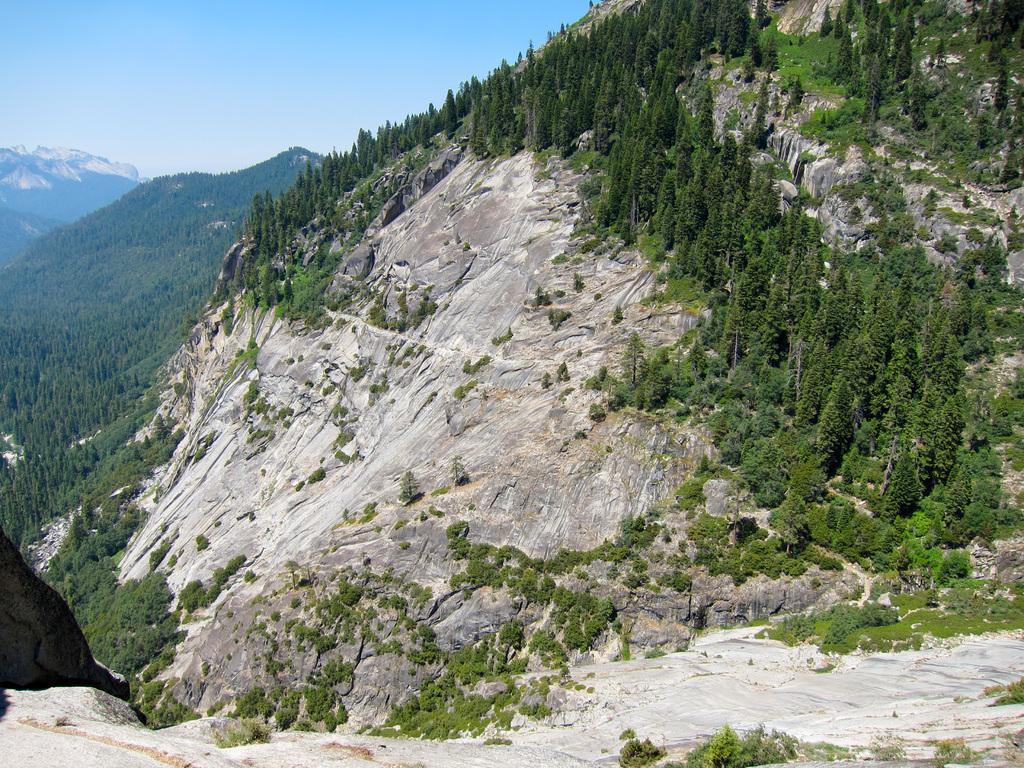Can you describe this image briefly? In this image, we can see so many trees, plants, rocks. Background we can see hills and clear sky. 